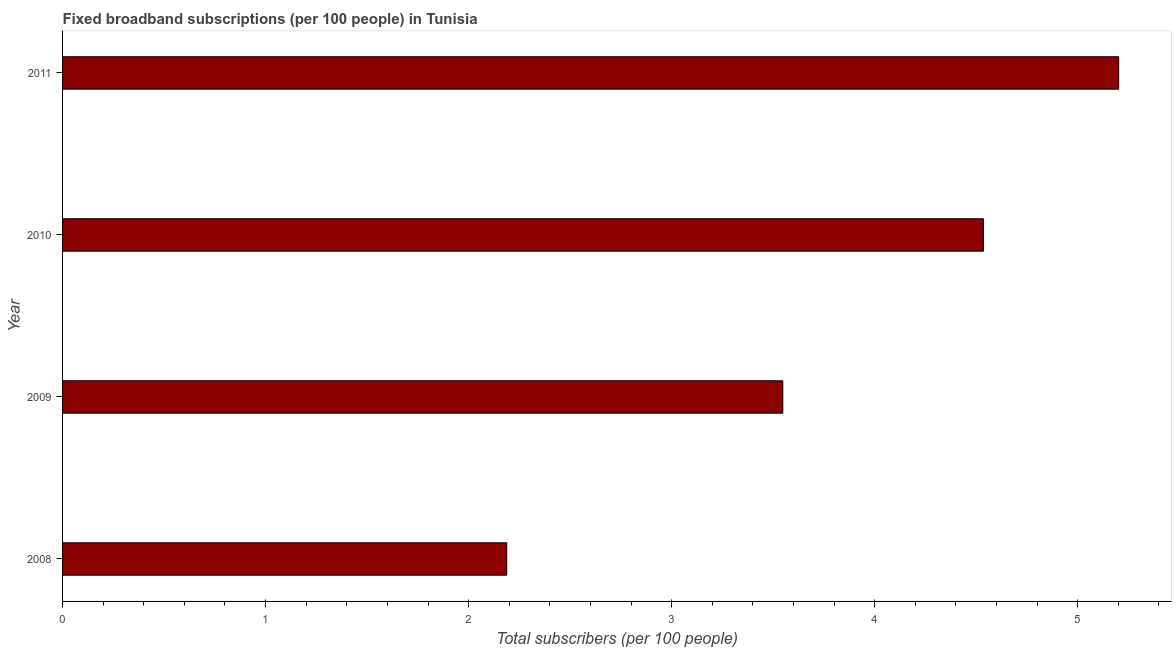Does the graph contain any zero values?
Your answer should be compact. No. Does the graph contain grids?
Give a very brief answer. No. What is the title of the graph?
Your answer should be very brief. Fixed broadband subscriptions (per 100 people) in Tunisia. What is the label or title of the X-axis?
Make the answer very short. Total subscribers (per 100 people). What is the total number of fixed broadband subscriptions in 2011?
Your answer should be very brief. 5.2. Across all years, what is the maximum total number of fixed broadband subscriptions?
Your response must be concise. 5.2. Across all years, what is the minimum total number of fixed broadband subscriptions?
Keep it short and to the point. 2.19. What is the sum of the total number of fixed broadband subscriptions?
Make the answer very short. 15.47. What is the difference between the total number of fixed broadband subscriptions in 2008 and 2011?
Make the answer very short. -3.01. What is the average total number of fixed broadband subscriptions per year?
Provide a succinct answer. 3.87. What is the median total number of fixed broadband subscriptions?
Provide a short and direct response. 4.04. Do a majority of the years between 2011 and 2010 (inclusive) have total number of fixed broadband subscriptions greater than 1.6 ?
Make the answer very short. No. What is the ratio of the total number of fixed broadband subscriptions in 2008 to that in 2010?
Offer a terse response. 0.48. Is the difference between the total number of fixed broadband subscriptions in 2008 and 2011 greater than the difference between any two years?
Your answer should be compact. Yes. What is the difference between the highest and the second highest total number of fixed broadband subscriptions?
Your response must be concise. 0.67. What is the difference between the highest and the lowest total number of fixed broadband subscriptions?
Provide a short and direct response. 3.01. How many bars are there?
Provide a succinct answer. 4. Are the values on the major ticks of X-axis written in scientific E-notation?
Provide a short and direct response. No. What is the Total subscribers (per 100 people) of 2008?
Make the answer very short. 2.19. What is the Total subscribers (per 100 people) of 2009?
Give a very brief answer. 3.55. What is the Total subscribers (per 100 people) in 2010?
Your answer should be compact. 4.54. What is the Total subscribers (per 100 people) in 2011?
Offer a very short reply. 5.2. What is the difference between the Total subscribers (per 100 people) in 2008 and 2009?
Give a very brief answer. -1.36. What is the difference between the Total subscribers (per 100 people) in 2008 and 2010?
Your answer should be compact. -2.35. What is the difference between the Total subscribers (per 100 people) in 2008 and 2011?
Offer a terse response. -3.01. What is the difference between the Total subscribers (per 100 people) in 2009 and 2010?
Your answer should be very brief. -0.99. What is the difference between the Total subscribers (per 100 people) in 2009 and 2011?
Your response must be concise. -1.65. What is the difference between the Total subscribers (per 100 people) in 2010 and 2011?
Make the answer very short. -0.67. What is the ratio of the Total subscribers (per 100 people) in 2008 to that in 2009?
Offer a terse response. 0.62. What is the ratio of the Total subscribers (per 100 people) in 2008 to that in 2010?
Provide a succinct answer. 0.48. What is the ratio of the Total subscribers (per 100 people) in 2008 to that in 2011?
Give a very brief answer. 0.42. What is the ratio of the Total subscribers (per 100 people) in 2009 to that in 2010?
Your response must be concise. 0.78. What is the ratio of the Total subscribers (per 100 people) in 2009 to that in 2011?
Make the answer very short. 0.68. What is the ratio of the Total subscribers (per 100 people) in 2010 to that in 2011?
Your answer should be compact. 0.87. 